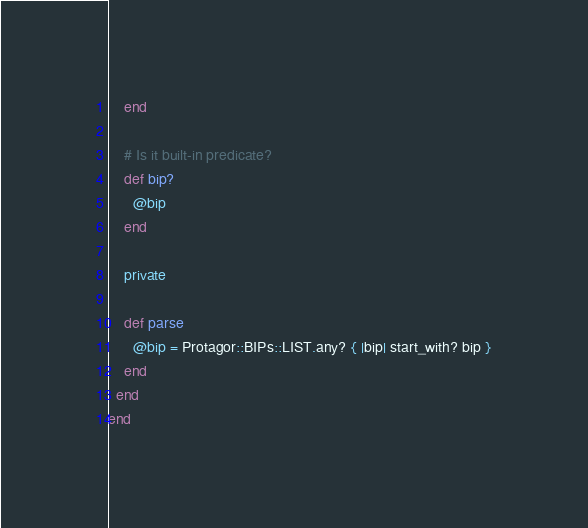Convert code to text. <code><loc_0><loc_0><loc_500><loc_500><_Ruby_>    end

    # Is it built-in predicate?
    def bip?
      @bip
    end

    private

    def parse
      @bip = Protagor::BIPs::LIST.any? { |bip| start_with? bip }
    end
  end
end
</code> 